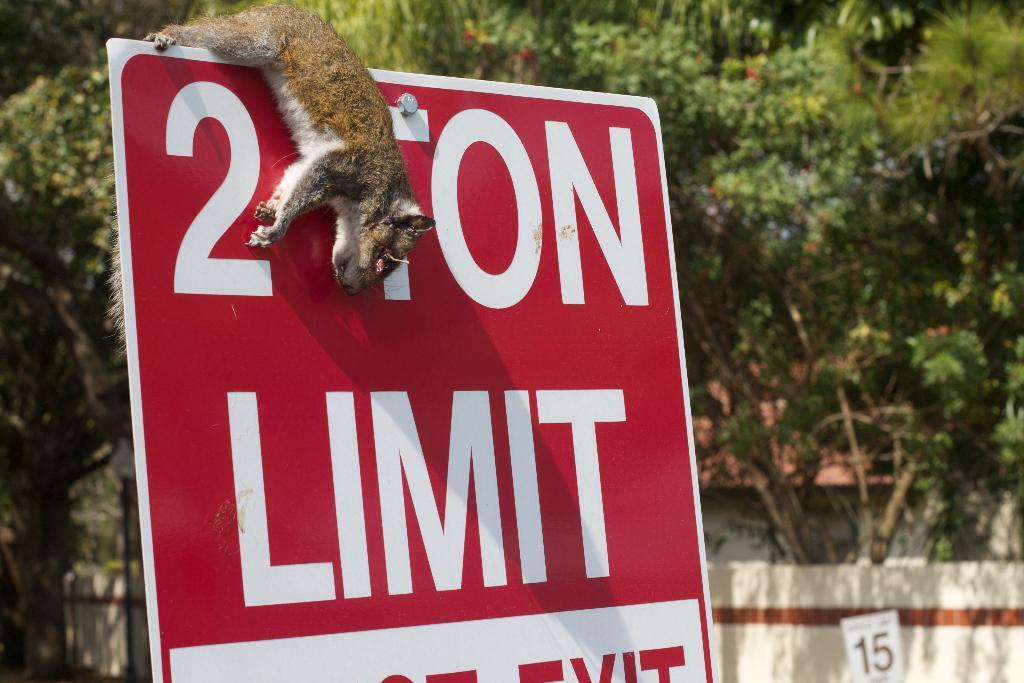What is the main object in the foreground of the image? There is a board in the foreground of the image. What is attached to the board? An animal is hanging on the board. What can be seen in the background of the image? There are trees, a fence, a pole, and a house in the background of the image. Can you describe the time of day when the image was taken? The image was likely taken during the day, as there is sufficient light to see the details clearly. Where is the maid standing in the image? There is no maid present in the image. What type of pump is visible in the image? There is no pump visible in the image. 